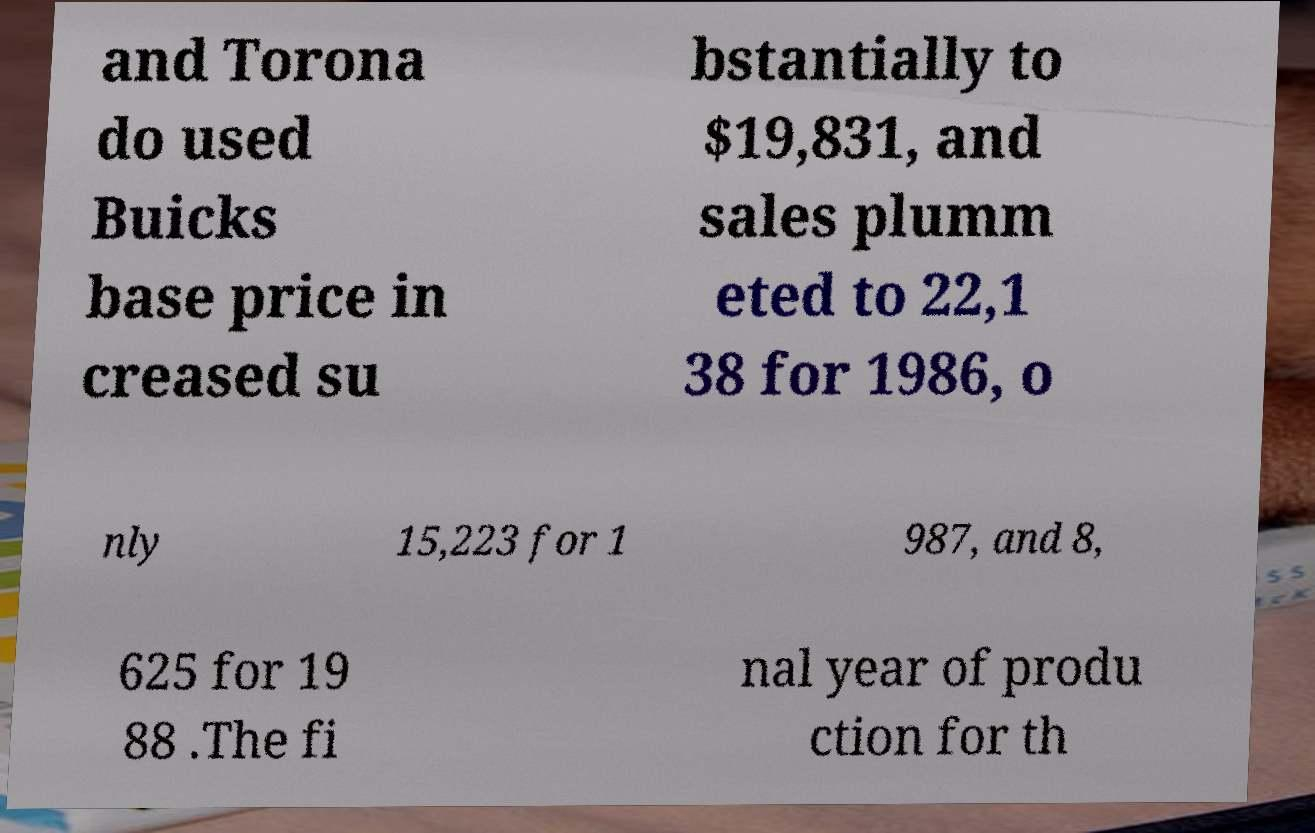Can you read and provide the text displayed in the image?This photo seems to have some interesting text. Can you extract and type it out for me? and Torona do used Buicks base price in creased su bstantially to $19,831, and sales plumm eted to 22,1 38 for 1986, o nly 15,223 for 1 987, and 8, 625 for 19 88 .The fi nal year of produ ction for th 